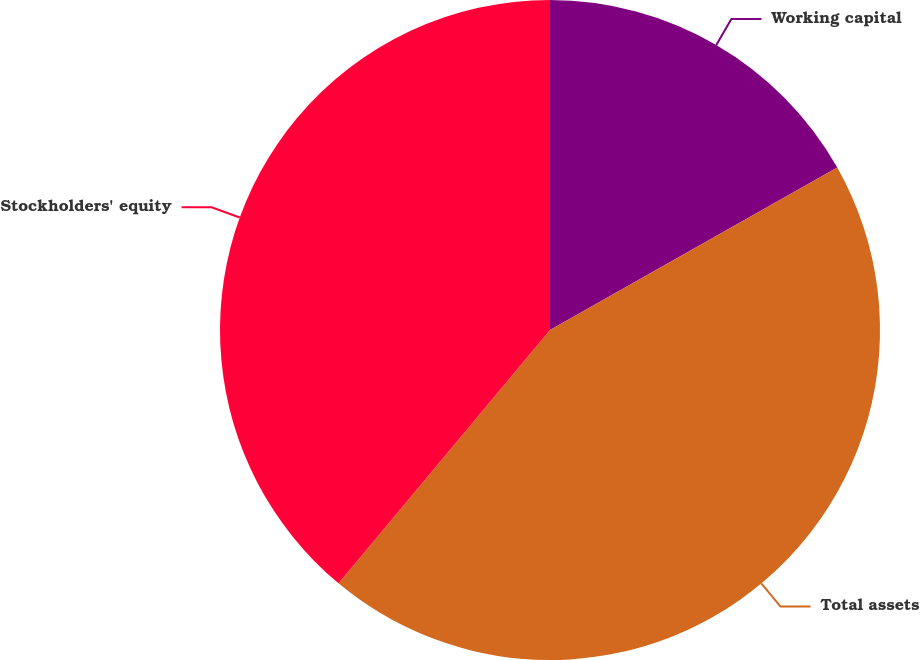Convert chart to OTSL. <chart><loc_0><loc_0><loc_500><loc_500><pie_chart><fcel>Working capital<fcel>Total assets<fcel>Stockholders' equity<nl><fcel>16.81%<fcel>44.26%<fcel>38.93%<nl></chart> 